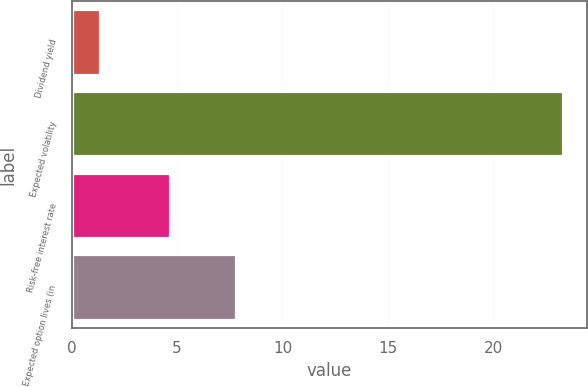Convert chart. <chart><loc_0><loc_0><loc_500><loc_500><bar_chart><fcel>Dividend yield<fcel>Expected volatility<fcel>Risk-free interest rate<fcel>Expected option lives (in<nl><fcel>1.34<fcel>23.3<fcel>4.69<fcel>7.8<nl></chart> 